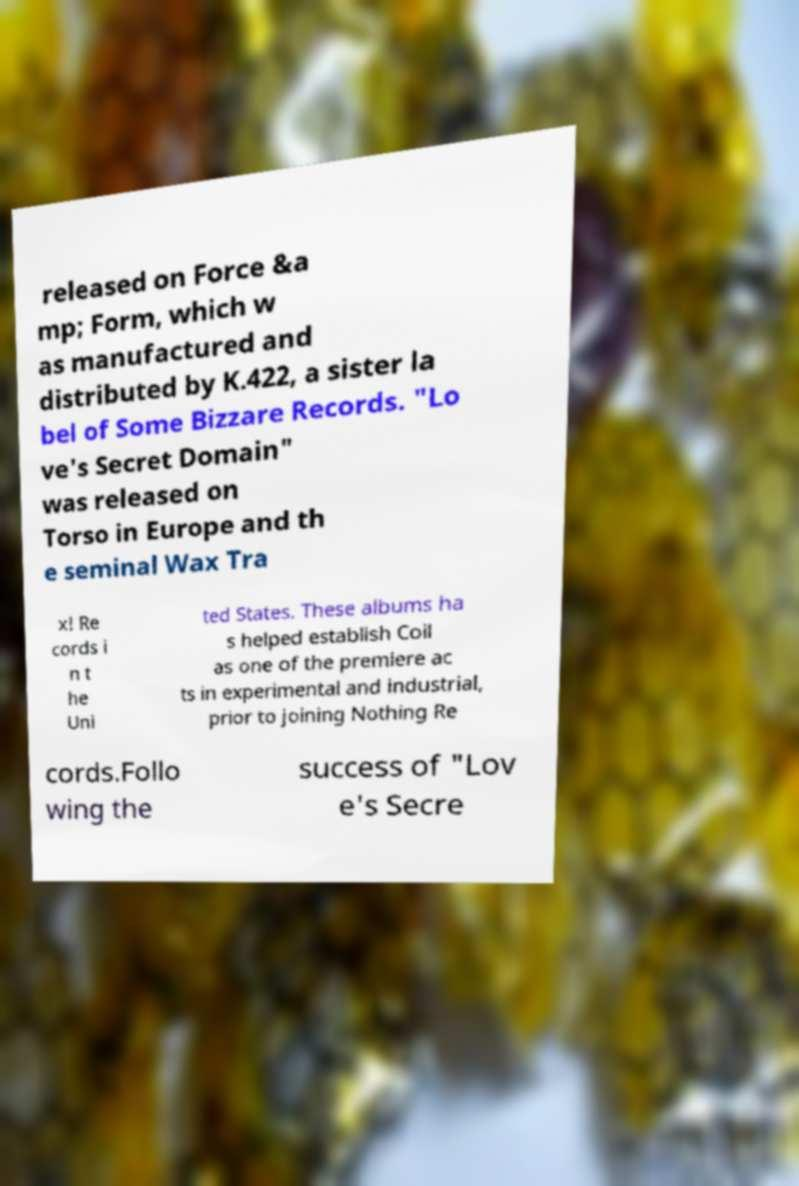Could you extract and type out the text from this image? released on Force &a mp; Form, which w as manufactured and distributed by K.422, a sister la bel of Some Bizzare Records. "Lo ve's Secret Domain" was released on Torso in Europe and th e seminal Wax Tra x! Re cords i n t he Uni ted States. These albums ha s helped establish Coil as one of the premiere ac ts in experimental and industrial, prior to joining Nothing Re cords.Follo wing the success of "Lov e's Secre 